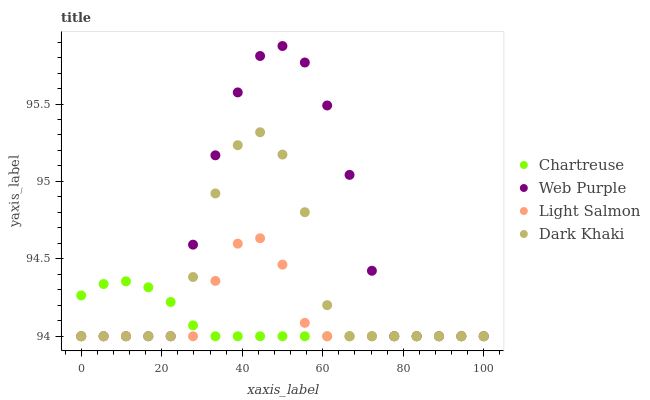Does Chartreuse have the minimum area under the curve?
Answer yes or no. Yes. Does Web Purple have the maximum area under the curve?
Answer yes or no. Yes. Does Web Purple have the minimum area under the curve?
Answer yes or no. No. Does Chartreuse have the maximum area under the curve?
Answer yes or no. No. Is Chartreuse the smoothest?
Answer yes or no. Yes. Is Web Purple the roughest?
Answer yes or no. Yes. Is Web Purple the smoothest?
Answer yes or no. No. Is Chartreuse the roughest?
Answer yes or no. No. Does Dark Khaki have the lowest value?
Answer yes or no. Yes. Does Web Purple have the highest value?
Answer yes or no. Yes. Does Chartreuse have the highest value?
Answer yes or no. No. Does Dark Khaki intersect Chartreuse?
Answer yes or no. Yes. Is Dark Khaki less than Chartreuse?
Answer yes or no. No. Is Dark Khaki greater than Chartreuse?
Answer yes or no. No. 